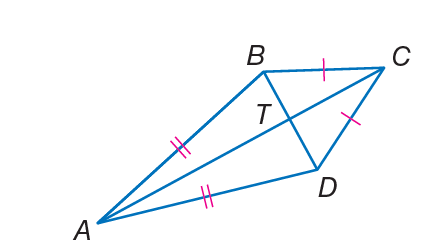If m \angle B A D = 38 and m \angle B C D = 50, find m \angle A D C. To find m \angle A D C, you must understand that the sum of the angles in a quadrilateral is 360 degrees. Here, we have a kite formed by points A, B, C, and D. In a kite, opposite angles are equal. We already have m \angle B A D = 38 and m \angle B C D = 50 degrees. Since angles BAD and BCD are opposite angles in the kite, and we are given that BAD is 38 degrees, we can deduce that angle ABC is also 38 degrees because it's opposite BAD. Now, knowing the measure of angle ABC, we can find angle ADC by subtracting the sum of the known angles from 360 degrees. Therefore, m \angle A D C = 360 - (38 + 38 + 50), which equals 234 degrees. The correct answer is not one of the choices provided, suggesting there might be an error in the question itself or the provided choices. 